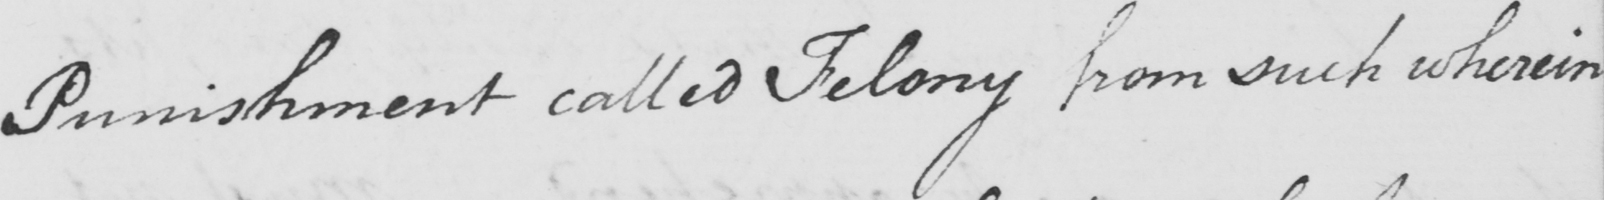What text is written in this handwritten line? Punishment called Felony from such wherein 